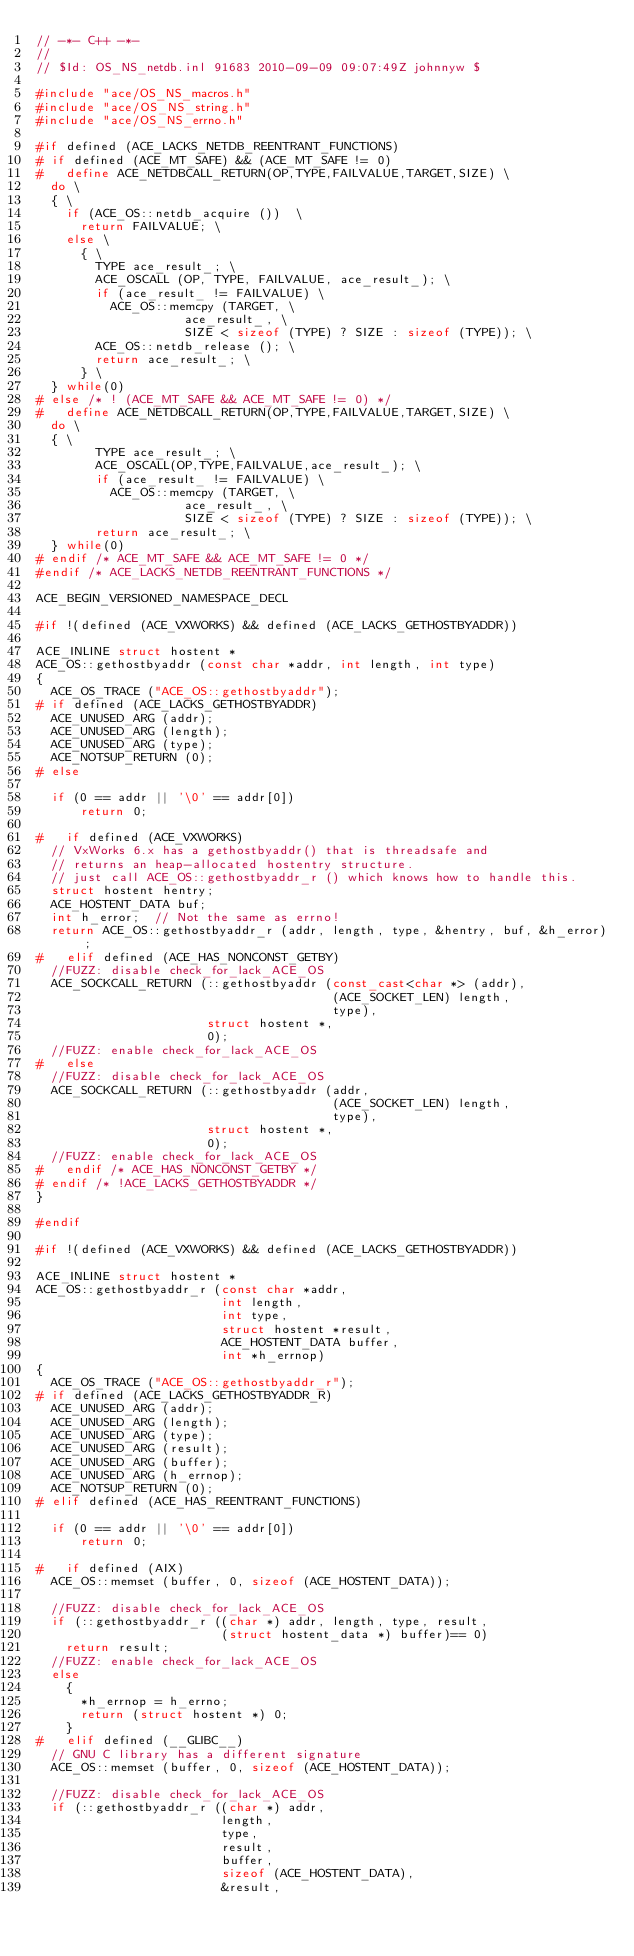Convert code to text. <code><loc_0><loc_0><loc_500><loc_500><_C++_>// -*- C++ -*-
//
// $Id: OS_NS_netdb.inl 91683 2010-09-09 09:07:49Z johnnyw $

#include "ace/OS_NS_macros.h"
#include "ace/OS_NS_string.h"
#include "ace/OS_NS_errno.h"

#if defined (ACE_LACKS_NETDB_REENTRANT_FUNCTIONS)
# if defined (ACE_MT_SAFE) && (ACE_MT_SAFE != 0)
#   define ACE_NETDBCALL_RETURN(OP,TYPE,FAILVALUE,TARGET,SIZE) \
  do \
  { \
    if (ACE_OS::netdb_acquire ())  \
      return FAILVALUE; \
    else \
      { \
        TYPE ace_result_; \
        ACE_OSCALL (OP, TYPE, FAILVALUE, ace_result_); \
        if (ace_result_ != FAILVALUE) \
          ACE_OS::memcpy (TARGET, \
                    ace_result_, \
                    SIZE < sizeof (TYPE) ? SIZE : sizeof (TYPE)); \
        ACE_OS::netdb_release (); \
        return ace_result_; \
      } \
  } while(0)
# else /* ! (ACE_MT_SAFE && ACE_MT_SAFE != 0) */
#   define ACE_NETDBCALL_RETURN(OP,TYPE,FAILVALUE,TARGET,SIZE) \
  do \
  { \
        TYPE ace_result_; \
        ACE_OSCALL(OP,TYPE,FAILVALUE,ace_result_); \
        if (ace_result_ != FAILVALUE) \
          ACE_OS::memcpy (TARGET, \
                    ace_result_, \
                    SIZE < sizeof (TYPE) ? SIZE : sizeof (TYPE)); \
        return ace_result_; \
  } while(0)
# endif /* ACE_MT_SAFE && ACE_MT_SAFE != 0 */
#endif /* ACE_LACKS_NETDB_REENTRANT_FUNCTIONS */

ACE_BEGIN_VERSIONED_NAMESPACE_DECL

#if !(defined (ACE_VXWORKS) && defined (ACE_LACKS_GETHOSTBYADDR))

ACE_INLINE struct hostent *
ACE_OS::gethostbyaddr (const char *addr, int length, int type)
{
  ACE_OS_TRACE ("ACE_OS::gethostbyaddr");
# if defined (ACE_LACKS_GETHOSTBYADDR)
  ACE_UNUSED_ARG (addr);
  ACE_UNUSED_ARG (length);
  ACE_UNUSED_ARG (type);
  ACE_NOTSUP_RETURN (0);
# else

  if (0 == addr || '\0' == addr[0])
      return 0;

#   if defined (ACE_VXWORKS)
  // VxWorks 6.x has a gethostbyaddr() that is threadsafe and
  // returns an heap-allocated hostentry structure.
  // just call ACE_OS::gethostbyaddr_r () which knows how to handle this.
  struct hostent hentry;
  ACE_HOSTENT_DATA buf;
  int h_error;  // Not the same as errno!
  return ACE_OS::gethostbyaddr_r (addr, length, type, &hentry, buf, &h_error);
#   elif defined (ACE_HAS_NONCONST_GETBY)
  //FUZZ: disable check_for_lack_ACE_OS
  ACE_SOCKCALL_RETURN (::gethostbyaddr (const_cast<char *> (addr),
                                        (ACE_SOCKET_LEN) length,
                                        type),
                       struct hostent *,
                       0);
  //FUZZ: enable check_for_lack_ACE_OS
#   else
  //FUZZ: disable check_for_lack_ACE_OS
  ACE_SOCKCALL_RETURN (::gethostbyaddr (addr,
                                        (ACE_SOCKET_LEN) length,
                                        type),
                       struct hostent *,
                       0);
  //FUZZ: enable check_for_lack_ACE_OS
#   endif /* ACE_HAS_NONCONST_GETBY */
# endif /* !ACE_LACKS_GETHOSTBYADDR */
}

#endif

#if !(defined (ACE_VXWORKS) && defined (ACE_LACKS_GETHOSTBYADDR))

ACE_INLINE struct hostent *
ACE_OS::gethostbyaddr_r (const char *addr,
                         int length,
                         int type,
                         struct hostent *result,
                         ACE_HOSTENT_DATA buffer,
                         int *h_errnop)
{
  ACE_OS_TRACE ("ACE_OS::gethostbyaddr_r");
# if defined (ACE_LACKS_GETHOSTBYADDR_R)
  ACE_UNUSED_ARG (addr);
  ACE_UNUSED_ARG (length);
  ACE_UNUSED_ARG (type);
  ACE_UNUSED_ARG (result);
  ACE_UNUSED_ARG (buffer);
  ACE_UNUSED_ARG (h_errnop);
  ACE_NOTSUP_RETURN (0);
# elif defined (ACE_HAS_REENTRANT_FUNCTIONS)

  if (0 == addr || '\0' == addr[0])
      return 0;

#   if defined (AIX)
  ACE_OS::memset (buffer, 0, sizeof (ACE_HOSTENT_DATA));

  //FUZZ: disable check_for_lack_ACE_OS
  if (::gethostbyaddr_r ((char *) addr, length, type, result,
                         (struct hostent_data *) buffer)== 0)
    return result;
  //FUZZ: enable check_for_lack_ACE_OS
  else
    {
      *h_errnop = h_errno;
      return (struct hostent *) 0;
    }
#   elif defined (__GLIBC__)
  // GNU C library has a different signature
  ACE_OS::memset (buffer, 0, sizeof (ACE_HOSTENT_DATA));

  //FUZZ: disable check_for_lack_ACE_OS
  if (::gethostbyaddr_r ((char *) addr,
                         length,
                         type,
                         result,
                         buffer,
                         sizeof (ACE_HOSTENT_DATA),
                         &result,</code> 